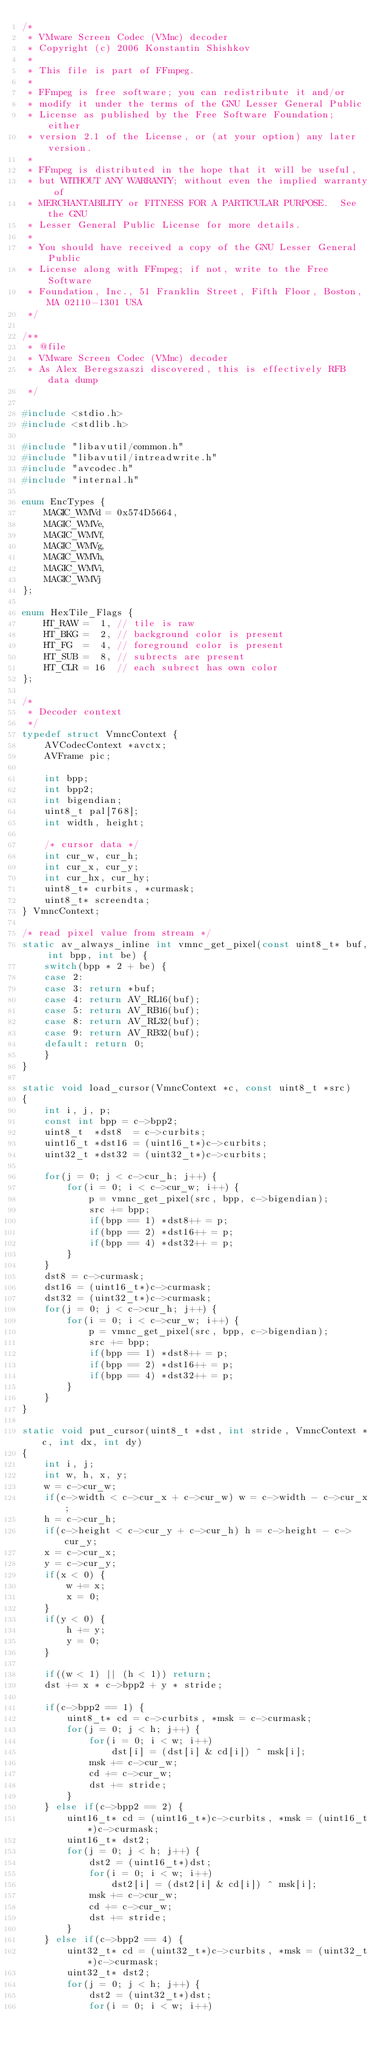Convert code to text. <code><loc_0><loc_0><loc_500><loc_500><_C_>/*
 * VMware Screen Codec (VMnc) decoder
 * Copyright (c) 2006 Konstantin Shishkov
 *
 * This file is part of FFmpeg.
 *
 * FFmpeg is free software; you can redistribute it and/or
 * modify it under the terms of the GNU Lesser General Public
 * License as published by the Free Software Foundation; either
 * version 2.1 of the License, or (at your option) any later version.
 *
 * FFmpeg is distributed in the hope that it will be useful,
 * but WITHOUT ANY WARRANTY; without even the implied warranty of
 * MERCHANTABILITY or FITNESS FOR A PARTICULAR PURPOSE.  See the GNU
 * Lesser General Public License for more details.
 *
 * You should have received a copy of the GNU Lesser General Public
 * License along with FFmpeg; if not, write to the Free Software
 * Foundation, Inc., 51 Franklin Street, Fifth Floor, Boston, MA 02110-1301 USA
 */

/**
 * @file
 * VMware Screen Codec (VMnc) decoder
 * As Alex Beregszaszi discovered, this is effectively RFB data dump
 */

#include <stdio.h>
#include <stdlib.h>

#include "libavutil/common.h"
#include "libavutil/intreadwrite.h"
#include "avcodec.h"
#include "internal.h"

enum EncTypes {
    MAGIC_WMVd = 0x574D5664,
    MAGIC_WMVe,
    MAGIC_WMVf,
    MAGIC_WMVg,
    MAGIC_WMVh,
    MAGIC_WMVi,
    MAGIC_WMVj
};

enum HexTile_Flags {
    HT_RAW =  1, // tile is raw
    HT_BKG =  2, // background color is present
    HT_FG  =  4, // foreground color is present
    HT_SUB =  8, // subrects are present
    HT_CLR = 16  // each subrect has own color
};

/*
 * Decoder context
 */
typedef struct VmncContext {
    AVCodecContext *avctx;
    AVFrame pic;

    int bpp;
    int bpp2;
    int bigendian;
    uint8_t pal[768];
    int width, height;

    /* cursor data */
    int cur_w, cur_h;
    int cur_x, cur_y;
    int cur_hx, cur_hy;
    uint8_t* curbits, *curmask;
    uint8_t* screendta;
} VmncContext;

/* read pixel value from stream */
static av_always_inline int vmnc_get_pixel(const uint8_t* buf, int bpp, int be) {
    switch(bpp * 2 + be) {
    case 2:
    case 3: return *buf;
    case 4: return AV_RL16(buf);
    case 5: return AV_RB16(buf);
    case 8: return AV_RL32(buf);
    case 9: return AV_RB32(buf);
    default: return 0;
    }
}

static void load_cursor(VmncContext *c, const uint8_t *src)
{
    int i, j, p;
    const int bpp = c->bpp2;
    uint8_t  *dst8  = c->curbits;
    uint16_t *dst16 = (uint16_t*)c->curbits;
    uint32_t *dst32 = (uint32_t*)c->curbits;

    for(j = 0; j < c->cur_h; j++) {
        for(i = 0; i < c->cur_w; i++) {
            p = vmnc_get_pixel(src, bpp, c->bigendian);
            src += bpp;
            if(bpp == 1) *dst8++ = p;
            if(bpp == 2) *dst16++ = p;
            if(bpp == 4) *dst32++ = p;
        }
    }
    dst8 = c->curmask;
    dst16 = (uint16_t*)c->curmask;
    dst32 = (uint32_t*)c->curmask;
    for(j = 0; j < c->cur_h; j++) {
        for(i = 0; i < c->cur_w; i++) {
            p = vmnc_get_pixel(src, bpp, c->bigendian);
            src += bpp;
            if(bpp == 1) *dst8++ = p;
            if(bpp == 2) *dst16++ = p;
            if(bpp == 4) *dst32++ = p;
        }
    }
}

static void put_cursor(uint8_t *dst, int stride, VmncContext *c, int dx, int dy)
{
    int i, j;
    int w, h, x, y;
    w = c->cur_w;
    if(c->width < c->cur_x + c->cur_w) w = c->width - c->cur_x;
    h = c->cur_h;
    if(c->height < c->cur_y + c->cur_h) h = c->height - c->cur_y;
    x = c->cur_x;
    y = c->cur_y;
    if(x < 0) {
        w += x;
        x = 0;
    }
    if(y < 0) {
        h += y;
        y = 0;
    }

    if((w < 1) || (h < 1)) return;
    dst += x * c->bpp2 + y * stride;

    if(c->bpp2 == 1) {
        uint8_t* cd = c->curbits, *msk = c->curmask;
        for(j = 0; j < h; j++) {
            for(i = 0; i < w; i++)
                dst[i] = (dst[i] & cd[i]) ^ msk[i];
            msk += c->cur_w;
            cd += c->cur_w;
            dst += stride;
        }
    } else if(c->bpp2 == 2) {
        uint16_t* cd = (uint16_t*)c->curbits, *msk = (uint16_t*)c->curmask;
        uint16_t* dst2;
        for(j = 0; j < h; j++) {
            dst2 = (uint16_t*)dst;
            for(i = 0; i < w; i++)
                dst2[i] = (dst2[i] & cd[i]) ^ msk[i];
            msk += c->cur_w;
            cd += c->cur_w;
            dst += stride;
        }
    } else if(c->bpp2 == 4) {
        uint32_t* cd = (uint32_t*)c->curbits, *msk = (uint32_t*)c->curmask;
        uint32_t* dst2;
        for(j = 0; j < h; j++) {
            dst2 = (uint32_t*)dst;
            for(i = 0; i < w; i++)</code> 